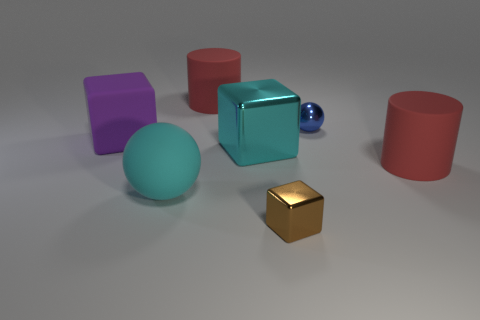Add 2 cyan rubber things. How many objects exist? 9 Subtract all cylinders. How many objects are left? 5 Subtract 0 gray cubes. How many objects are left? 7 Subtract all gray cubes. Subtract all rubber blocks. How many objects are left? 6 Add 7 blue balls. How many blue balls are left? 8 Add 3 large brown shiny balls. How many large brown shiny balls exist? 3 